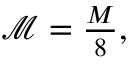<formula> <loc_0><loc_0><loc_500><loc_500>\begin{array} { r } { \mathcal { M } = \frac { M } { 8 } , } \end{array}</formula> 